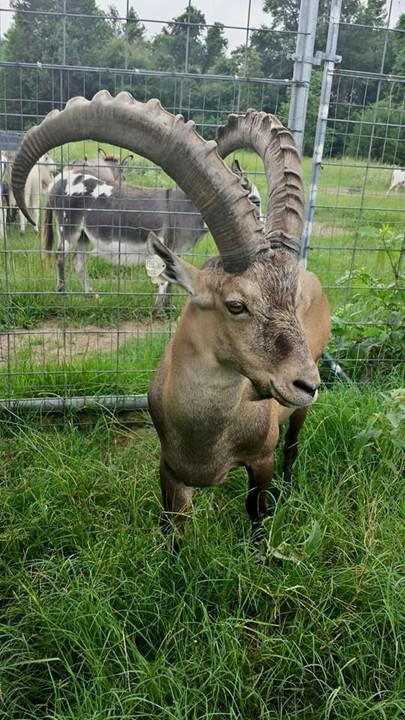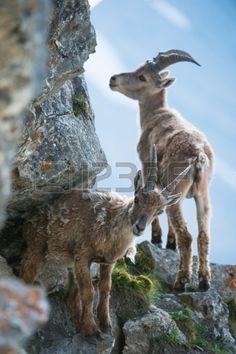The first image is the image on the left, the second image is the image on the right. Given the left and right images, does the statement "A different kind of animal is behind a sheep with a large set of horns in one image." hold true? Answer yes or no. Yes. The first image is the image on the left, the second image is the image on the right. For the images displayed, is the sentence "The sky can be seen in the image on the right." factually correct? Answer yes or no. Yes. 